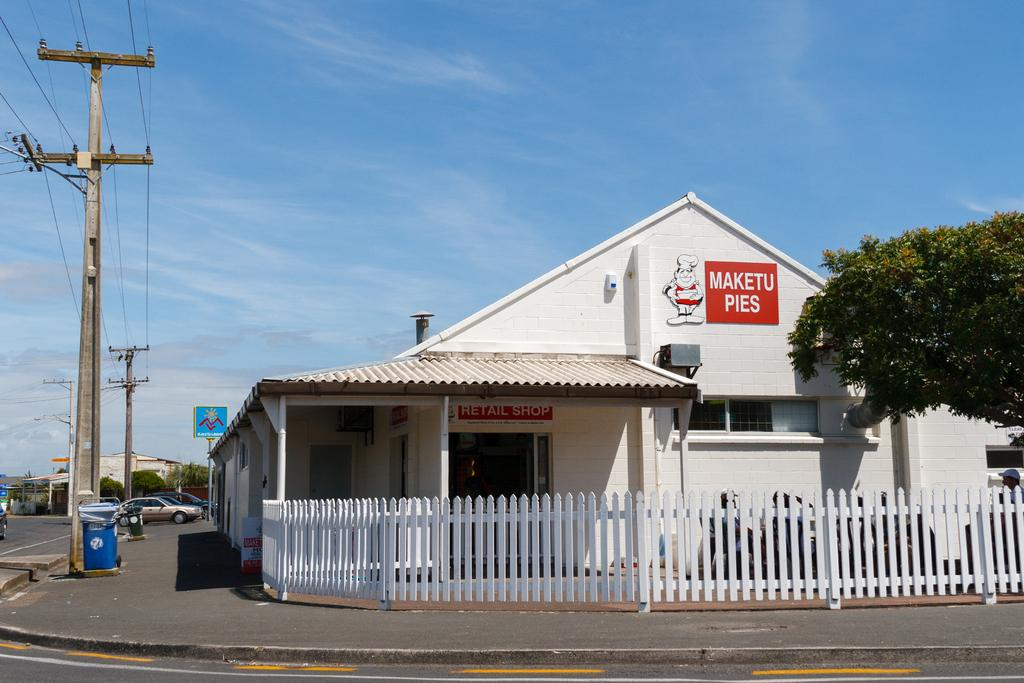What is the color of the sky in the image? The sky is blue in the image. What type of structures can be seen in the image? There are buildings in the image. What other natural elements are present in the image? There are trees in the image. What objects are related to advertising or information in the image? There are boards and current polls in the image. What objects are used for waste disposal in the image? There are bins in the image. What type of barrier is present in the image? There is a fence in the image. What type of transportation is visible in the image? There are vehicles in the image. How many deer can be seen grazing in the image? There are no deer present in the image. What type of sheep can be seen in the image? There are no sheep present in the image. 